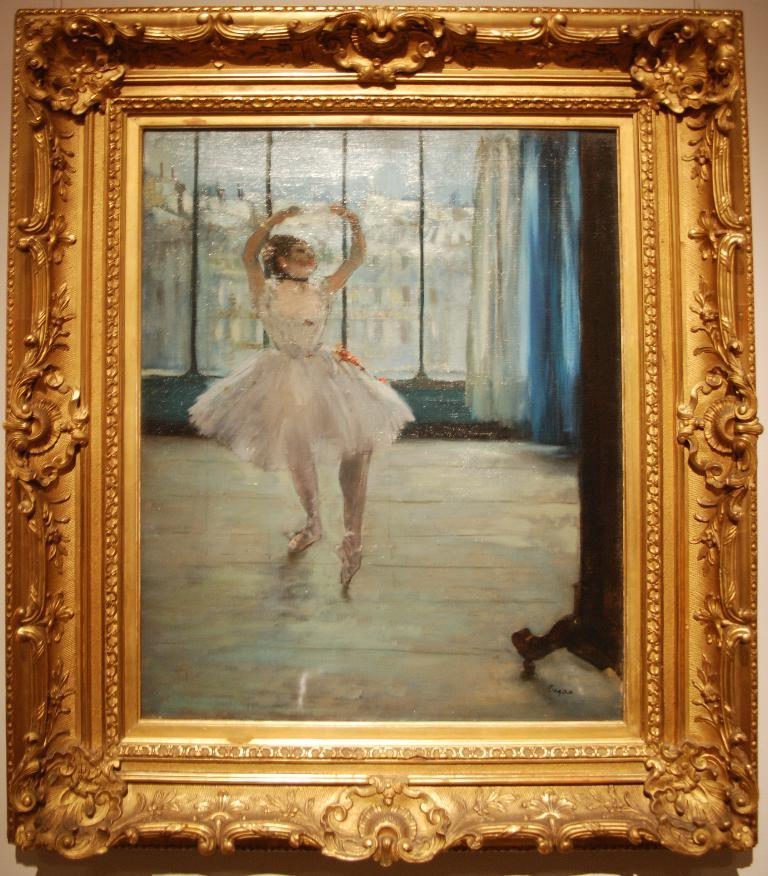What object is present in the picture that contains an image? There is a photo frame in the picture. What is depicted in the photo within the frame? The photo contains a painting of a woman. Can you describe any additional elements in the painting? There are other things visible in the painting, but the specific details are not mentioned in the provided facts. What type of vest is the woman wearing in the painting? There is no information about the woman's clothing in the provided facts, so we cannot determine if she is wearing a vest or any other specific garment. 